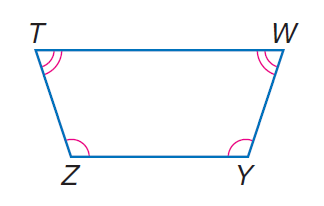Answer the mathemtical geometry problem and directly provide the correct option letter.
Question: isosceles trapezoid T W Y Z with \angle Z \cong \angle Y, m \angle Z = 30 x, \angle T \cong \angle W, and m \angle T = 20 x, find \angle T.
Choices: A: 62 B: 72 C: 108 D: 118 B 